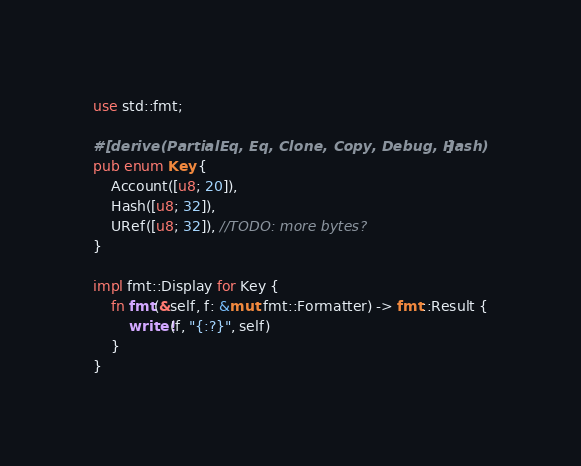Convert code to text. <code><loc_0><loc_0><loc_500><loc_500><_Rust_>use std::fmt;

#[derive(PartialEq, Eq, Clone, Copy, Debug, Hash)]
pub enum Key {
    Account([u8; 20]),
    Hash([u8; 32]),
    URef([u8; 32]), //TODO: more bytes?
}

impl fmt::Display for Key {
    fn fmt(&self, f: &mut fmt::Formatter) -> fmt::Result {
        write!(f, "{:?}", self)
    }
}
</code> 